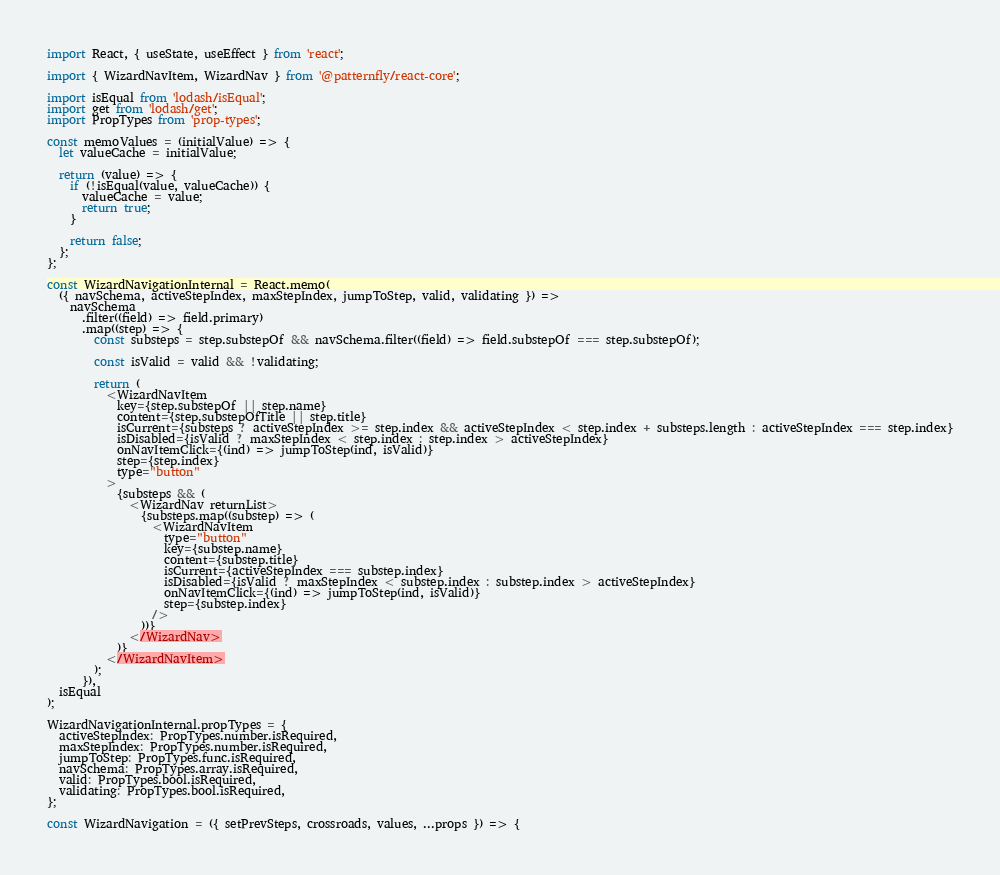Convert code to text. <code><loc_0><loc_0><loc_500><loc_500><_JavaScript_>import React, { useState, useEffect } from 'react';

import { WizardNavItem, WizardNav } from '@patternfly/react-core';

import isEqual from 'lodash/isEqual';
import get from 'lodash/get';
import PropTypes from 'prop-types';

const memoValues = (initialValue) => {
  let valueCache = initialValue;

  return (value) => {
    if (!isEqual(value, valueCache)) {
      valueCache = value;
      return true;
    }

    return false;
  };
};

const WizardNavigationInternal = React.memo(
  ({ navSchema, activeStepIndex, maxStepIndex, jumpToStep, valid, validating }) =>
    navSchema
      .filter((field) => field.primary)
      .map((step) => {
        const substeps = step.substepOf && navSchema.filter((field) => field.substepOf === step.substepOf);

        const isValid = valid && !validating;

        return (
          <WizardNavItem
            key={step.substepOf || step.name}
            content={step.substepOfTitle || step.title}
            isCurrent={substeps ? activeStepIndex >= step.index && activeStepIndex < step.index + substeps.length : activeStepIndex === step.index}
            isDisabled={isValid ? maxStepIndex < step.index : step.index > activeStepIndex}
            onNavItemClick={(ind) => jumpToStep(ind, isValid)}
            step={step.index}
            type="button"
          >
            {substeps && (
              <WizardNav returnList>
                {substeps.map((substep) => (
                  <WizardNavItem
                    type="button"
                    key={substep.name}
                    content={substep.title}
                    isCurrent={activeStepIndex === substep.index}
                    isDisabled={isValid ? maxStepIndex < substep.index : substep.index > activeStepIndex}
                    onNavItemClick={(ind) => jumpToStep(ind, isValid)}
                    step={substep.index}
                  />
                ))}
              </WizardNav>
            )}
          </WizardNavItem>
        );
      }),
  isEqual
);

WizardNavigationInternal.propTypes = {
  activeStepIndex: PropTypes.number.isRequired,
  maxStepIndex: PropTypes.number.isRequired,
  jumpToStep: PropTypes.func.isRequired,
  navSchema: PropTypes.array.isRequired,
  valid: PropTypes.bool.isRequired,
  validating: PropTypes.bool.isRequired,
};

const WizardNavigation = ({ setPrevSteps, crossroads, values, ...props }) => {</code> 